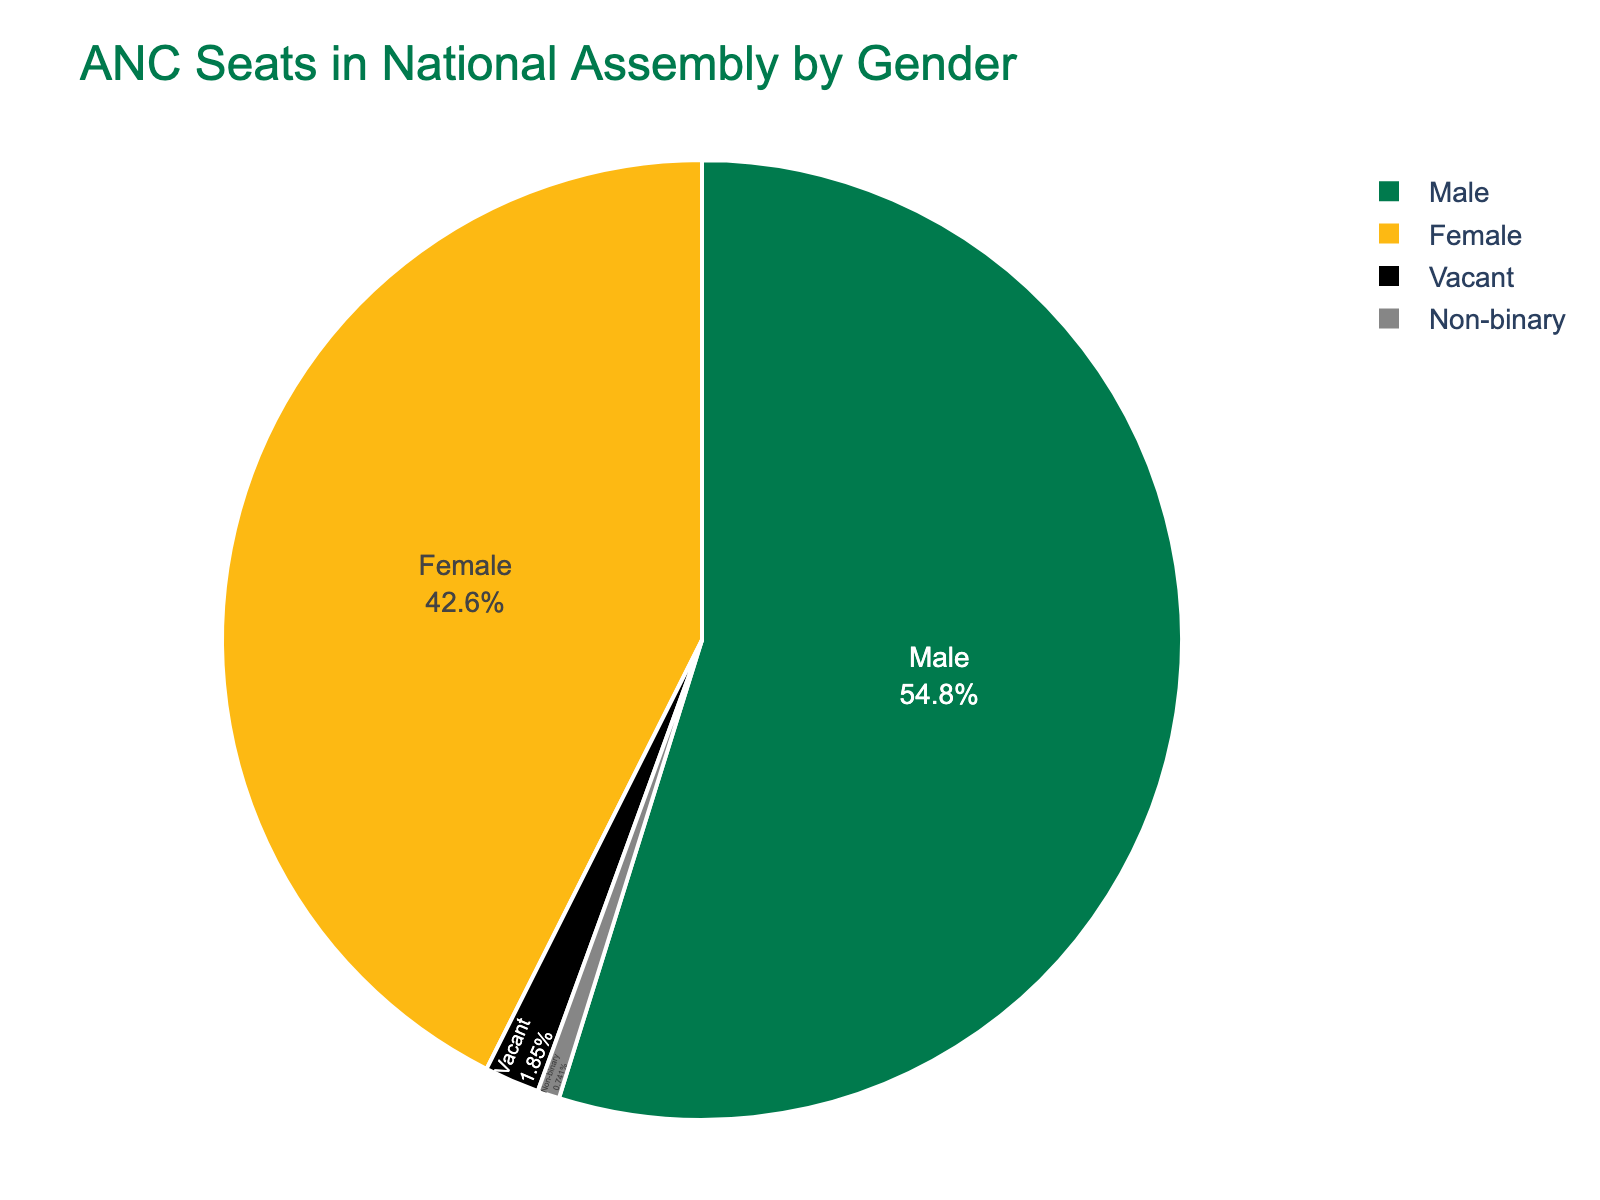Which gender has the highest number of ANC seats in the National Assembly? From the pie chart, it is clear that the Male category occupies the largest portion. By looking at the chart, you can see that the Male segment is the most dominant.
Answer: Male How many more ANC seats do males have compared to females? Males have 148 seats while females have 115 seats. To find the difference, subtract 115 from 148, which is 33.
Answer: 33 What percentage of ANC seats are held by non-binary representatives? The pie chart shows that non-binary representatives hold 2 seats out of a total of 270 seats (148 + 115 + 2 + 5 = 270). To find the percentage, divide 2 by 270 and multiply by 100. This gives approximately 0.74%.
Answer: 0.74% What is the combined percentage of seats held by females and vacant seats? Females have 42.6% and vacant seats have 1.9%. Adding these percentages together gives 42.6 + 1.9 = 44.5%.
Answer: 44.5% Which category has the smallest portion of ANC seats? The "Non-binary" category has the smallest portion as it is evidently a very small segment in the pie chart.
Answer: Non-binary How does the number of vacant seats compare to the number of non-binary seats? The chart displays that vacant seats are 5 and non-binary seats are 2. Since 5 is greater than 2, vacant seats are more than non-binary seats.
Answer: Vacant seats are greater If 10 more female representatives were added to the ANC in the National Assembly, what would be the new total of female representatives? The current number of female seats is 115. Adding 10 to this number results in 115 + 10 = 125.
Answer: 125 What is the total number of ANC seats in the National Assembly according to the chart? Sum the seats from all categories: 148 (Male) + 115 (Female) + 2 (Non-binary) + 5 (Vacant) = 270 seats.
Answer: 270 What proportion of the seats are vacant? Vacant seats are 5 out of a total 270 seats. To find the proportion, divide 5 by 270 which results in approximately 0.0185. Multiplying this by 100 gives 1.85%.
Answer: 1.85% 